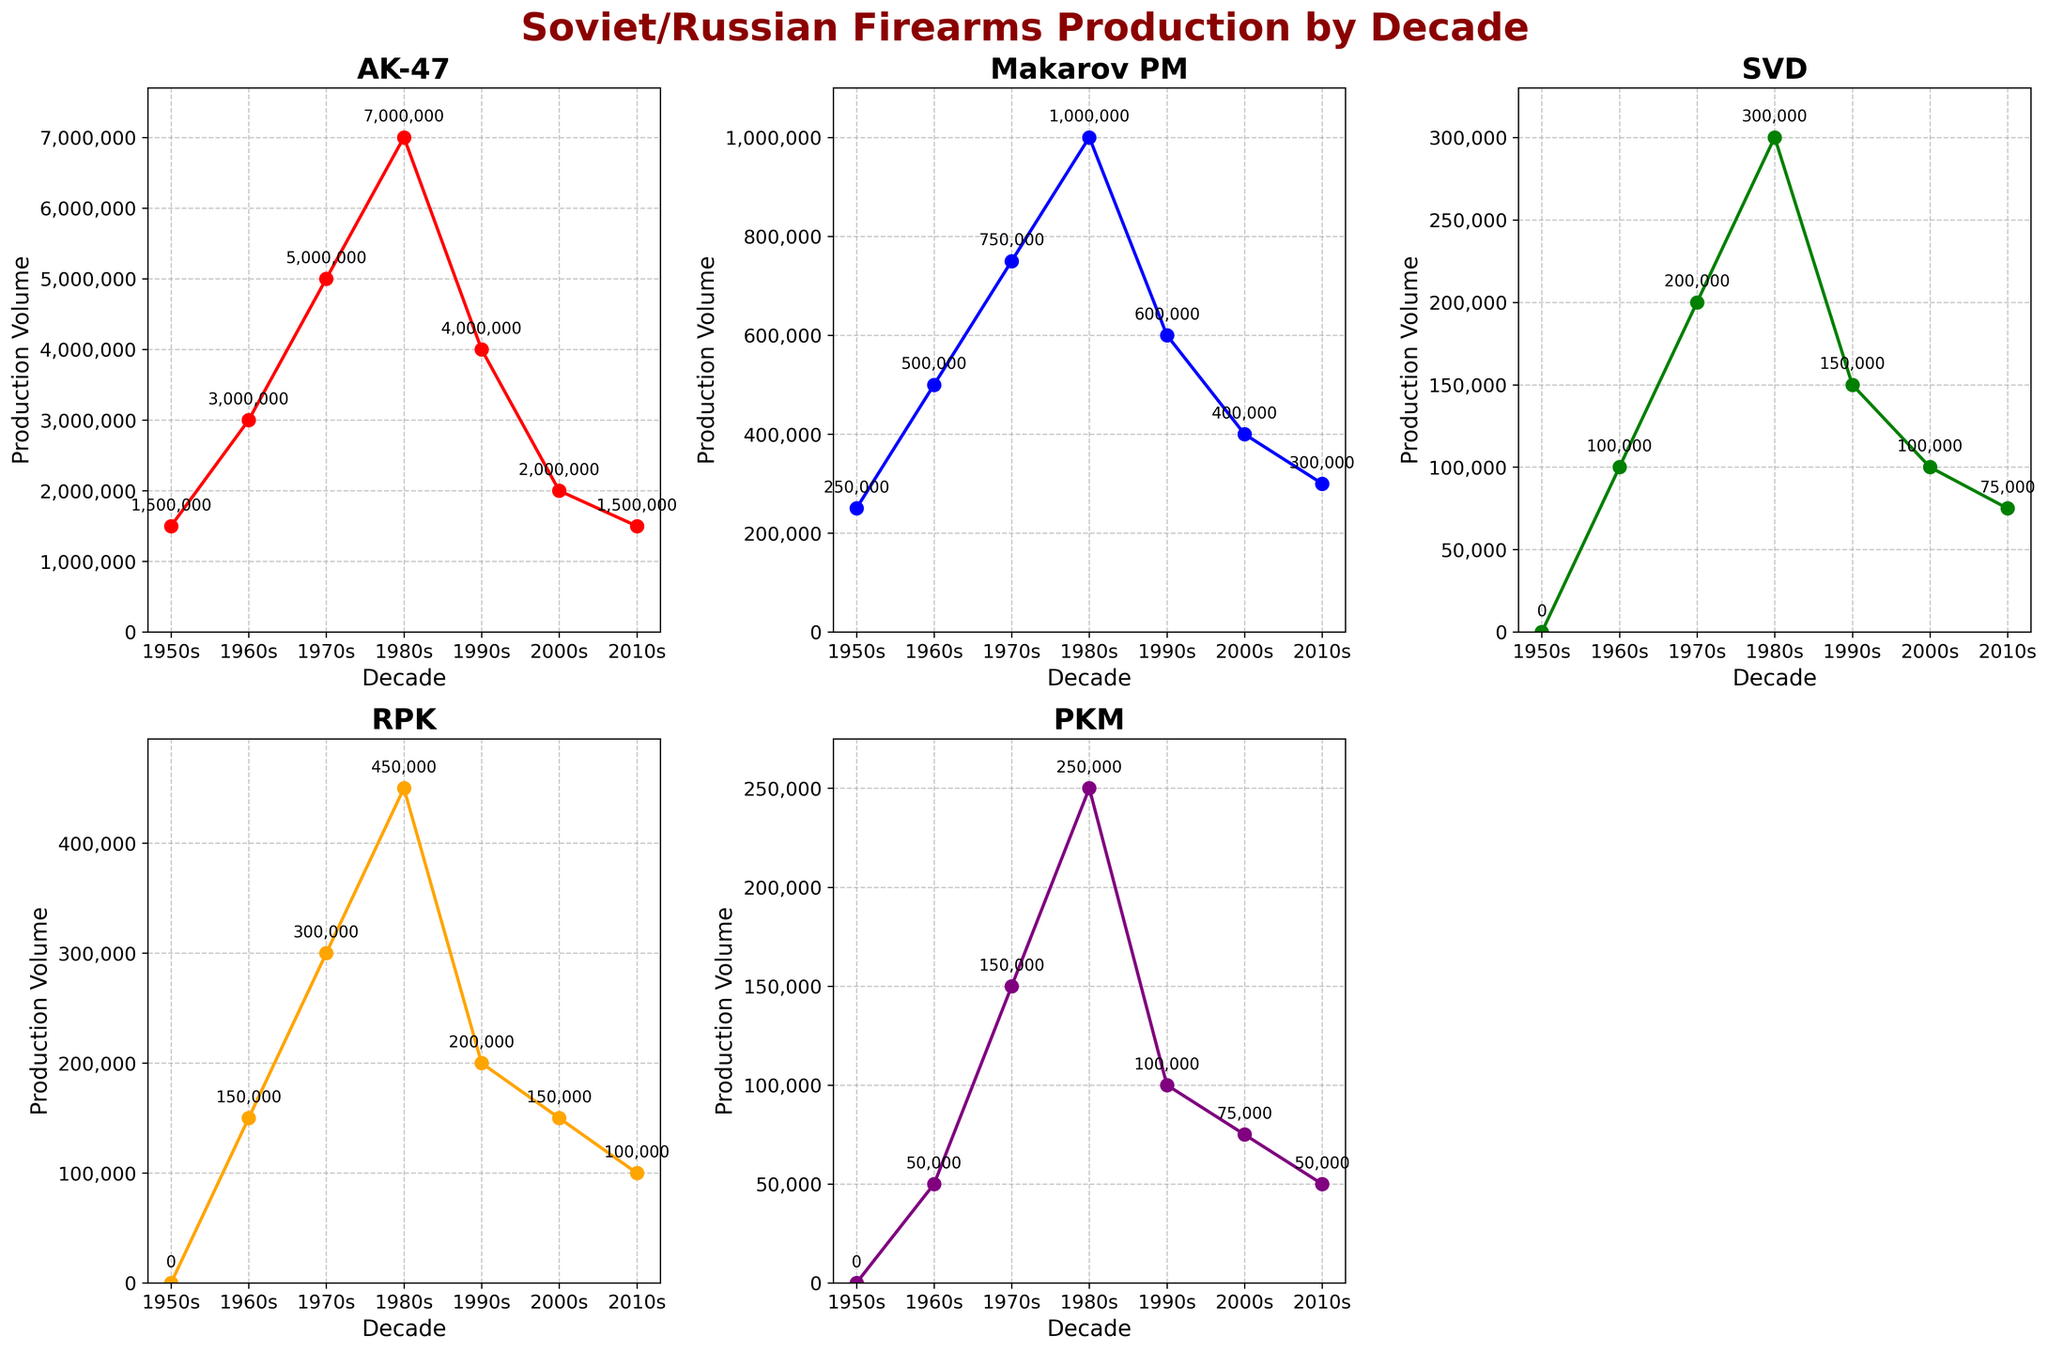What is the title of the figure? The title of the figure is displayed at the top of the chart, usually providing an overall description of the data being presented.
Answer: Soviet/Russian Firearms Production by Decade How many markers are there in the subplot for the AK-47? The number of markers corresponds to the data points plotted on the AK-47 subplot, each representing a decade.
Answer: 7 Which firearm had the highest production volume in the 1970s? To find this, we need to look at the 1970s data in each subplot and find the highest value.
Answer: AK-47 How much did the production volume of the AK-47 decrease from the 1980s to the 1990s? Subtract the production volume in the 1990s (4,000,000) from the 1980s (7,000,000).
Answer: 3,000,000 What is the total production volume of the Makarov PM from the 1950s to the 2010s? Sum the Makarov PM production values across all decades: 250,000 + 500,000 + 750,000 + 1,000,000 + 600,000 + 400,000 + 300,000.
Answer: 3,800,000 Which decade saw the first production of the SVD? Locate the first decade where the SVD production volume is greater than zero.
Answer: 1960s Which firearm had the least consistent production volume across the decades? Compare the fluctuations in production volumes across decades for each firearm.
Answer: SVD How much more was the AK-47 produced in the 1960s compared to the PKM in the 1960s? Subtract the PKM's production volume in the 1960s (50,000) from the AK-47's production volume in the same decade (3,000,000).
Answer: 2,950,000 What are the y-axis labels indicating in each subplot? The y-axis labels indicate the production volume of each firearm. The labels are formatted with commas for readability.
Answer: Production Volume 